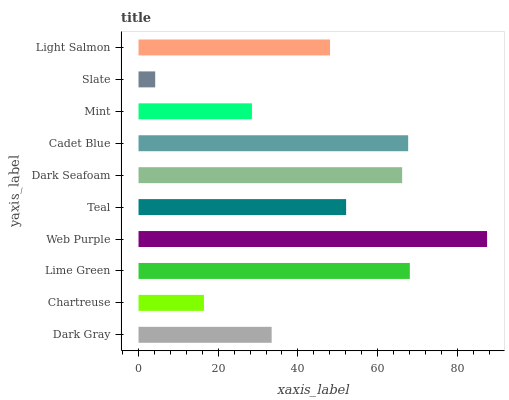Is Slate the minimum?
Answer yes or no. Yes. Is Web Purple the maximum?
Answer yes or no. Yes. Is Chartreuse the minimum?
Answer yes or no. No. Is Chartreuse the maximum?
Answer yes or no. No. Is Dark Gray greater than Chartreuse?
Answer yes or no. Yes. Is Chartreuse less than Dark Gray?
Answer yes or no. Yes. Is Chartreuse greater than Dark Gray?
Answer yes or no. No. Is Dark Gray less than Chartreuse?
Answer yes or no. No. Is Teal the high median?
Answer yes or no. Yes. Is Light Salmon the low median?
Answer yes or no. Yes. Is Slate the high median?
Answer yes or no. No. Is Slate the low median?
Answer yes or no. No. 